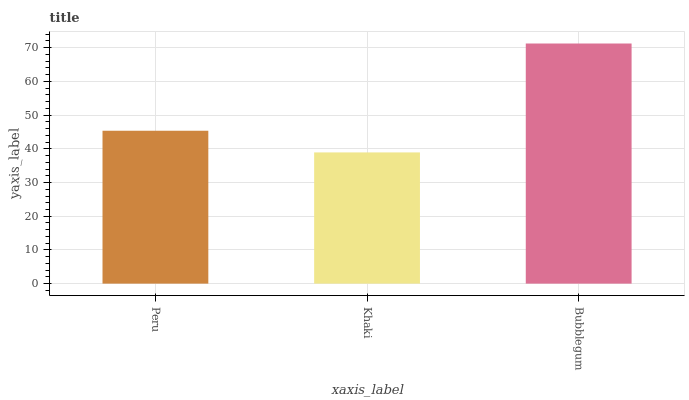Is Khaki the minimum?
Answer yes or no. Yes. Is Bubblegum the maximum?
Answer yes or no. Yes. Is Bubblegum the minimum?
Answer yes or no. No. Is Khaki the maximum?
Answer yes or no. No. Is Bubblegum greater than Khaki?
Answer yes or no. Yes. Is Khaki less than Bubblegum?
Answer yes or no. Yes. Is Khaki greater than Bubblegum?
Answer yes or no. No. Is Bubblegum less than Khaki?
Answer yes or no. No. Is Peru the high median?
Answer yes or no. Yes. Is Peru the low median?
Answer yes or no. Yes. Is Khaki the high median?
Answer yes or no. No. Is Bubblegum the low median?
Answer yes or no. No. 